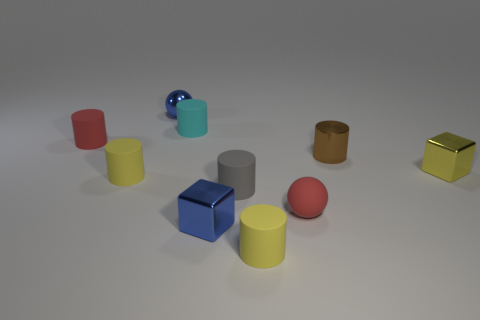Subtract all purple cubes. How many yellow cylinders are left? 2 Subtract all red rubber cylinders. How many cylinders are left? 5 Subtract 4 cylinders. How many cylinders are left? 2 Subtract all yellow cylinders. How many cylinders are left? 4 Subtract all yellow cylinders. Subtract all purple spheres. How many cylinders are left? 4 Subtract all cylinders. How many objects are left? 4 Subtract all tiny metal cylinders. Subtract all tiny gray rubber blocks. How many objects are left? 9 Add 2 yellow rubber cylinders. How many yellow rubber cylinders are left? 4 Add 9 blue matte blocks. How many blue matte blocks exist? 9 Subtract 1 red cylinders. How many objects are left? 9 